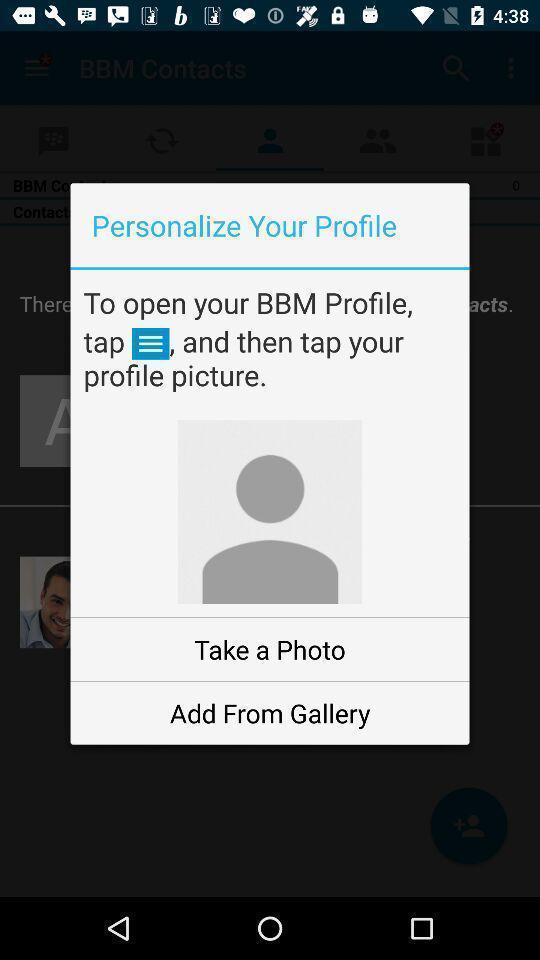Provide a detailed account of this screenshot. Pop-up with profile options in a messaging service app. 